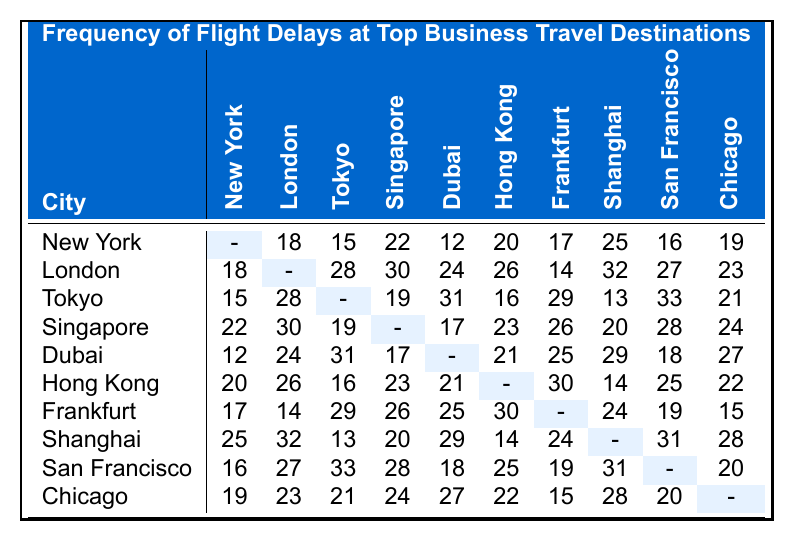What is the delay frequency for flights from New York to London? The table shows the delay frequency values for flights between New York and London. Looking at the corresponding cell in the row for New York and column for London, the value is 18.
Answer: 18 Which city has the highest flight delay frequency to Chicago? To find this, we look at the row for each city and find the corresponding value in the Chicago column. The maximum value is 27, found in the Dubai row.
Answer: Dubai What is the total flight delay frequency from San Francisco to all other cities? We sum the delay frequencies from San Francisco to all other cities: 16 (to New York) + 27 (to London) + 33 (to Tokyo) + 28 (to Singapore) + 18 (to Dubai) + 25 (to Hong Kong) + 19 (to Frankfurt) + 31 (to Shanghai) + 20 (to Chicago) =  24 + 28 + 18 + 25 + 19 + 31 + 20 = 241.
Answer: 241 Is the flight from Hong Kong to Shanghai more frequently delayed than from Shanghai to Hong Kong? The table shows the delay frequency from Hong Kong to Shanghai is 14, while from Shanghai to Hong Kong it is 30. Thus, the frequency is higher from Shanghai to Hong Kong than vice versa.
Answer: No What is the average flight delay frequency from Tokyo to all other cities? To find the average, we sum the values in the Tokyo row: 15 (to New York) + 28 (to London) + 19 (to Singapore) + 31 (to Dubai) + 16 (to Hong Kong) + 29 (to Frankfurt) + 13 (to Shanghai) + 33 (to San Francisco) + 21 (to Chicago) =  15 + 28 + 19 + 31 + 16 + 29 + 13 + 33 + 21 = 285. Now we divide by 9 (since there are 9 flights): 285 / 9 = 31.67 (rounded to 31.7).
Answer: 31.7 Which city experiences the least delay from Frankfurt? Looking at the Frankfurt row, the delay frequencies to other cities are: 17 (New York), 14 (London), 29 (Tokyo), 26 (Singapore), 25 (Dubai), 30 (Hong Kong), 24 (Shanghai), 19 (San Francisco), and 15 (Chicago). The minimum value is 14 to London, showing it's the least delayed flight from Frankfurt.
Answer: London Is the flight delay from Singapore to Tokyo the same as from Tokyo to Singapore? The table provides the values: Singapore to Tokyo is 19 and Tokyo to Singapore is 31; they are not the same.
Answer: No Calculate the difference in delay between Dubai to Tokyo and Tokyo to Dubai. The delay from Dubai to Tokyo is 31 while from Tokyo to Dubai it is 17. The difference is calculated as 31 - 17 = 14.
Answer: 14 Which city has the highest pairwise delay frequency with New York, and what is that frequency? We check all values in the New York row: it shows delays to London (18), Tokyo (15), Singapore (22), Dubai (12), Hong Kong (20), Frankfurt (17), Shanghai (25), San Francisco (16), and Chicago (19). The maximum is 25 towards Shanghai.
Answer: Shanghai, 25 What is the least frequent delay among all the entries for Dubai? The delays from Dubai to other cities are 12 (to New York), 24 (to London), 31 (to Tokyo), 17 (to Singapore), and 21 (to Hong Kong), 25 (to Frankfurt), 29 (to Shanghai), 18 (to San Francisco), 27 (to Chicago). The least frequent delay is 12 (to New York).
Answer: 12 How does the delay from San Francisco compare to the average of the delays from Chicago? From San Francisco, the delays are 16 (to New York), 27 (to London), 33 (to Tokyo), 28 (to Singapore), 18 (to Dubai), 25 (to Hong Kong), 19 (to Frankfurt), 31 (to Shanghai), and 20 (to Chicago). The total is 25 + 24 + 20 + 19 + 26 + 27 + 33 + 24 + 21 = 27. The average from Chicago is 20 (to New York), 23 (to London), 21 (to Tokyo), 24 (to Singapore), 27 (to Dubai), 22 (to Hong Kong), 15 (to Frankfurt), 28 (to Shanghai), and 20 (to San Francisco). The average is (20 + 23 + 21 + 24 + 27 + 22 + 15 + 28 + 20) / 9 = 18. The value from San Francisco (24) is less than the averaged (18).
Answer: No 